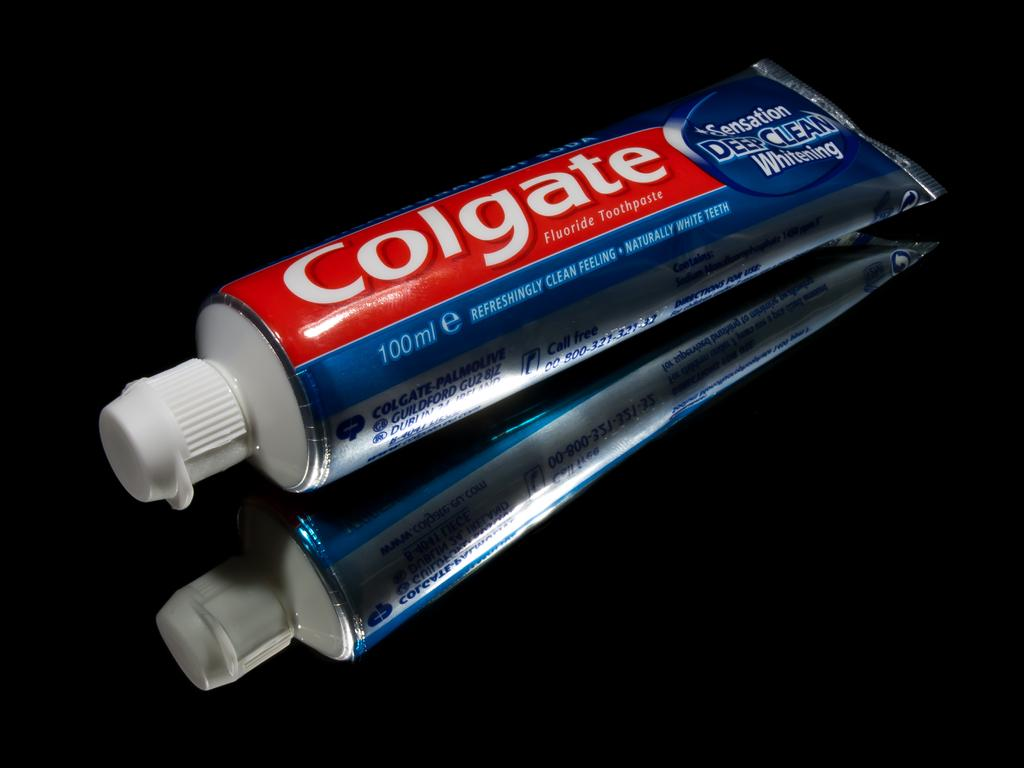What object is visible in the image? There is a toothpaste in the image. Where is the toothpaste located? The toothpaste is placed on a surface. Can you describe the appearance of the toothpaste in the image? The toothpaste has a reflection in the image. What is the color of the background in the image? The background of the image is dark. How many mice are hiding behind the toothpaste in the image? There are no mice present in the image. What type of memory is stored in the toothpaste in the image? Toothpaste does not have memory, as it is a personal care product used for oral hygiene. 